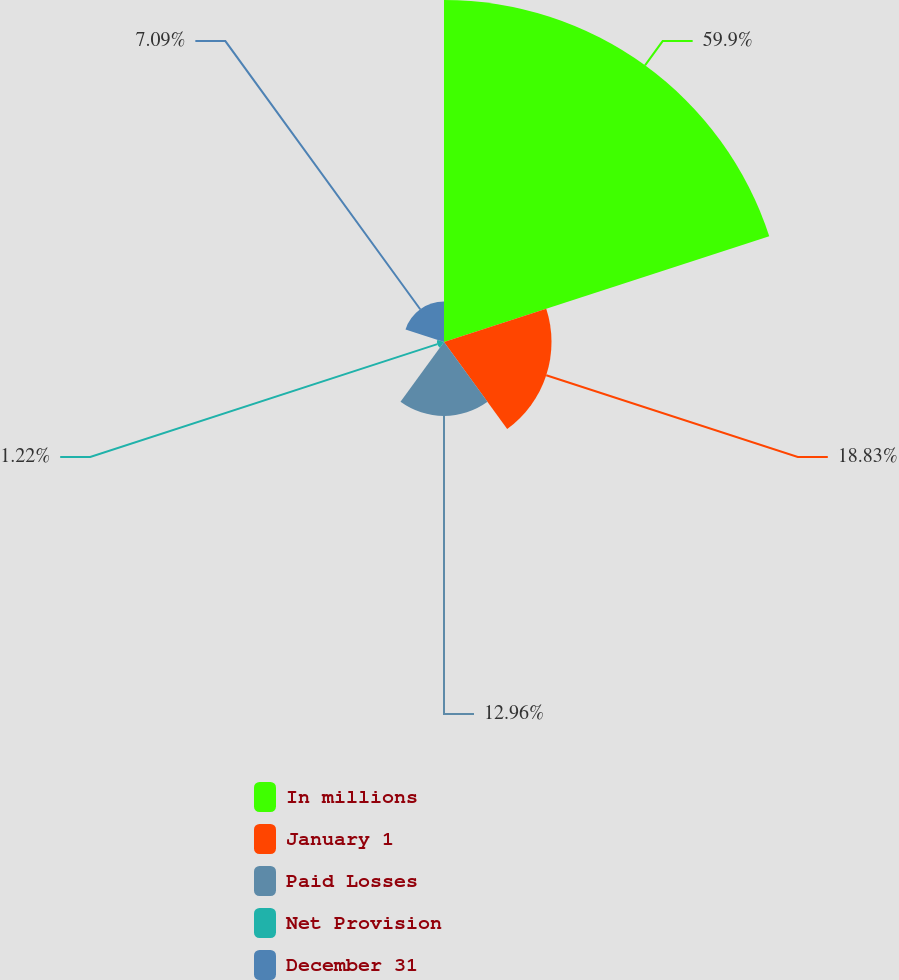Convert chart to OTSL. <chart><loc_0><loc_0><loc_500><loc_500><pie_chart><fcel>In millions<fcel>January 1<fcel>Paid Losses<fcel>Net Provision<fcel>December 31<nl><fcel>59.9%<fcel>18.83%<fcel>12.96%<fcel>1.22%<fcel>7.09%<nl></chart> 